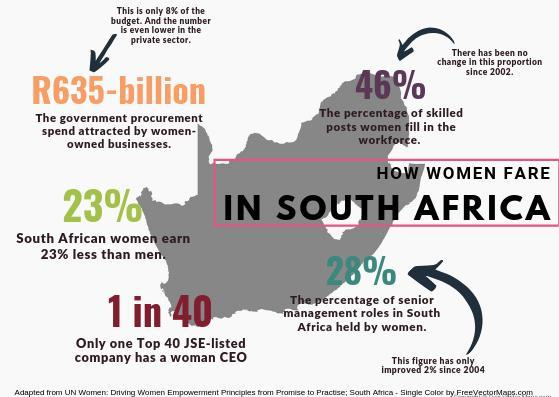In the year 2003, has there been a change in the percentage of skilled women in workforce?
Answer the question with a short phrase. no change What is increase in percentage of skilled women in workforce in 2004, 28%, 46%, or 23%? 46% What is percentage of men earning in South Africa? 77% 